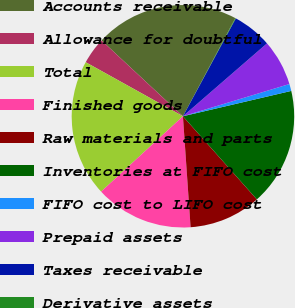<chart> <loc_0><loc_0><loc_500><loc_500><pie_chart><fcel>Accounts receivable<fcel>Allowance for doubtful<fcel>Total<fcel>Finished goods<fcel>Raw materials and parts<fcel>Inventories at FIFO cost<fcel>FIFO cost to LIFO cost<fcel>Prepaid assets<fcel>Taxes receivable<fcel>Derivative assets<nl><fcel>20.87%<fcel>3.86%<fcel>19.92%<fcel>14.25%<fcel>10.47%<fcel>17.09%<fcel>1.02%<fcel>6.69%<fcel>5.75%<fcel>0.08%<nl></chart> 